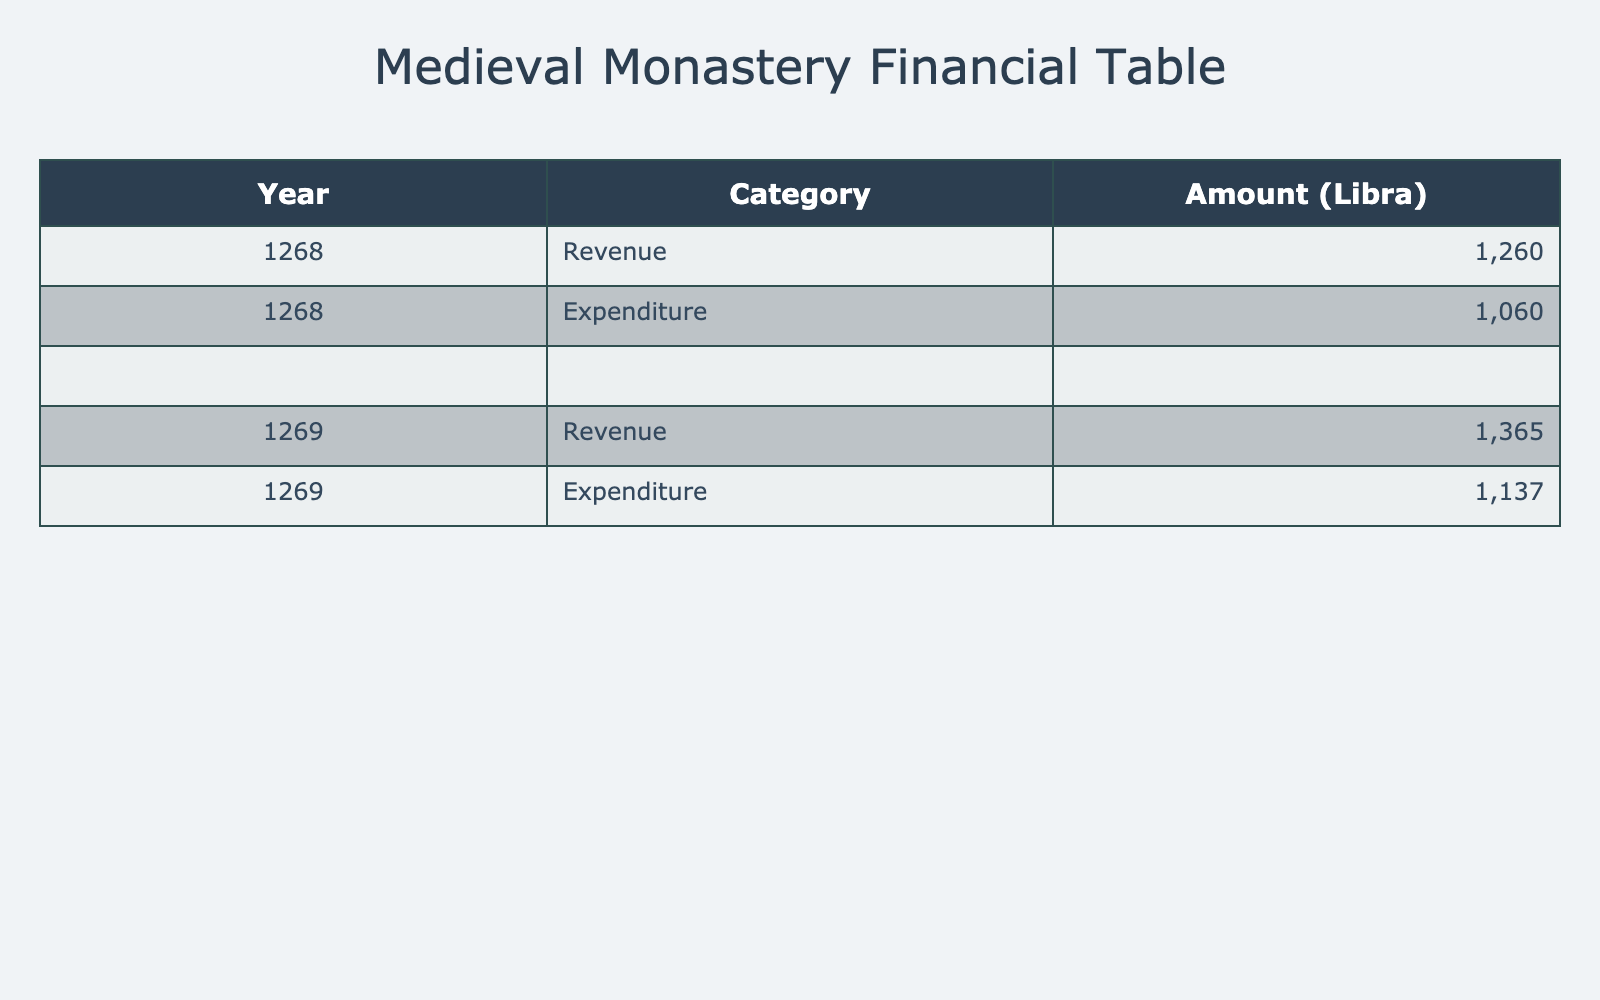What was the total revenue for the year 1268? The total revenue for the year 1268 is calculated by summing all revenue sources for that year. The specific values are: 100 + 150 + 80 + 90 + 20 + 300 + 400 + 50 + 70 = 1260.
Answer: 1260 What was the total expenditure in the year 1269? To find the total expenditure for 1269, I will sum all expenditures for that year: 55 + 210 + 160 + 320 + 90 + 65 + 45 + 12 + 105 + 75 = 1,032.
Answer: 1,032 Is the amount spent on construction and maintenance in 1268 greater than in 1269? In 1268, the expenditure for construction and maintenance was 150. In 1269, it was 160. Since 150 is less than 160, the statement is false.
Answer: No Which year saw greater revenue from livestock sales? For livestock sales, in 1268, the revenue was 90, while in 1269, it was 95. Since 95 is higher than 90, 1269 had greater revenue.
Answer: 1269 What was the average revenue from grain sales over the two years? I will calculate the average revenue from grain sales by finding the total for both years (150 in 1268 and 160 in 1269). The sum is 150 + 160 = 310. There are 2 years, so the average is 310 / 2 = 155.
Answer: 155 What is the difference between total donations from nobility in the years 1268 and 1269? The donations from nobility are 400 in 1268 and 450 in 1269. The difference can be calculated as follows: 450 - 400 = 50.
Answer: 50 Is the total amount spent on taxes to the crown over the two years less than or equal to 200? The expenditures for taxes to the crown were 100 for 1268 and 105 for 1269. The total spent is 100 + 105 = 205, which is greater than 200. The statement is false.
Answer: No Which category had higher total amounts: revenue or expenditure for the year 1268? The total revenue for 1268 is 1,260, while the total expenditure for the same year is 1,040 (50 + 200 + 150 + 300 + 80 + 60 + 40 + 10 + 100 + 70). Since 1,260 is greater than 1,040, revenue was higher.
Answer: Revenue What was the total amount spent on feasts and hospitality in both years? The expenditure for feasts and hospitality in 1268 was 70, and in 1269 it was 75. The total for both years is 70 + 75 = 145.
Answer: 145 